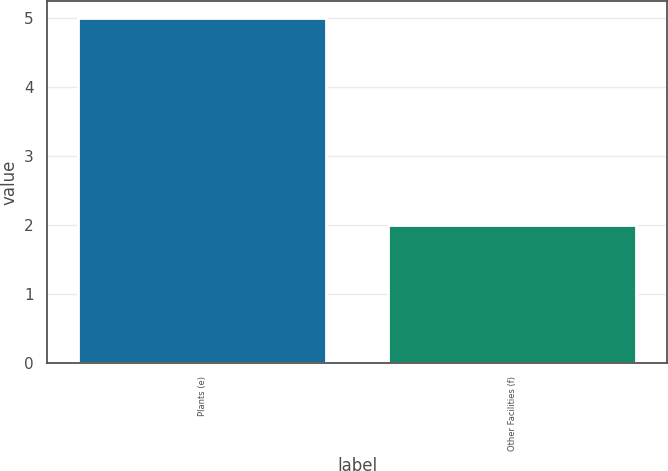Convert chart. <chart><loc_0><loc_0><loc_500><loc_500><bar_chart><fcel>Plants (e)<fcel>Other Facilities (f)<nl><fcel>5<fcel>2<nl></chart> 